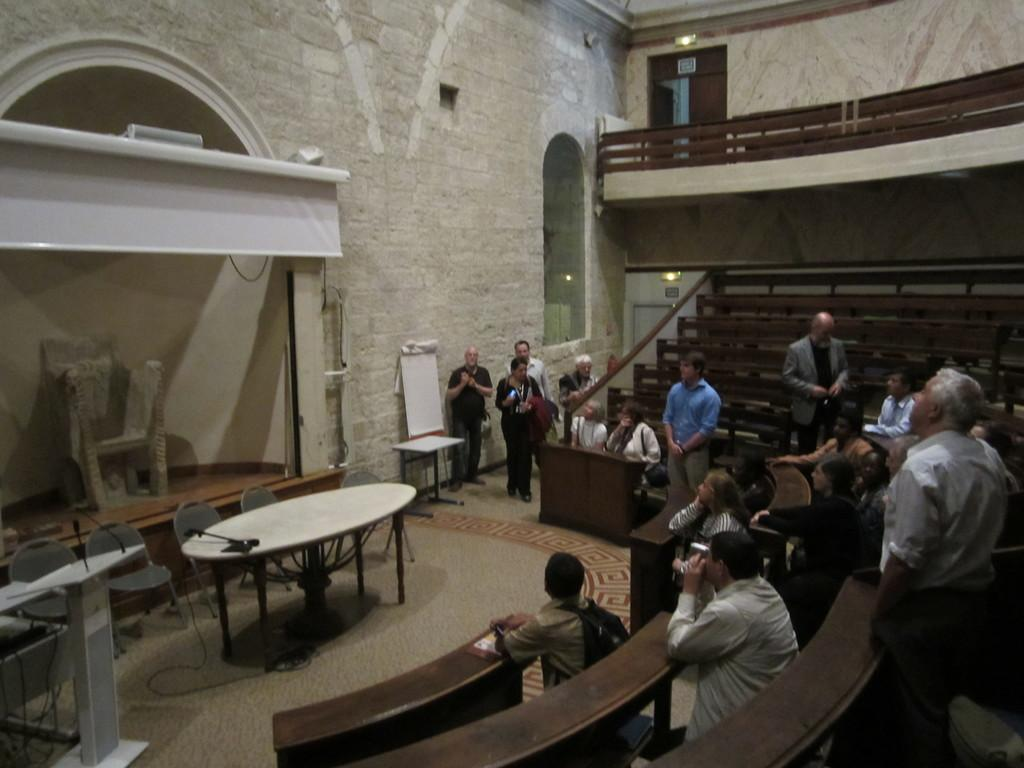What are the persons in the image sitting or standing? In the image, there are persons sitting on benches and persons standing. What is the location of the scene in the image? The setting of the image is a room. What furniture can be seen in the room? There are tables and chairs in the room. What is near the wall in the room? There is a board near the wall in the room. What architectural feature is present in the room? There is an arch in the room. How many rabbits can be seen grazing on the bushes in the image? There are no rabbits or bushes present in the image; it features a room with persons sitting and standing, furniture, a board, and an arch. 